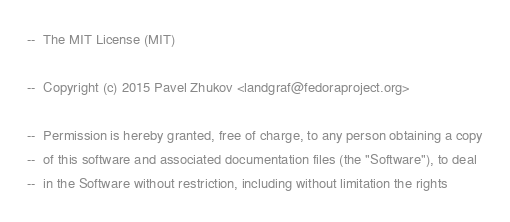<code> <loc_0><loc_0><loc_500><loc_500><_Ada_>--  The MIT License (MIT)

--  Copyright (c) 2015 Pavel Zhukov <landgraf@fedoraproject.org>

--  Permission is hereby granted, free of charge, to any person obtaining a copy
--  of this software and associated documentation files (the "Software"), to deal
--  in the Software without restriction, including without limitation the rights</code> 